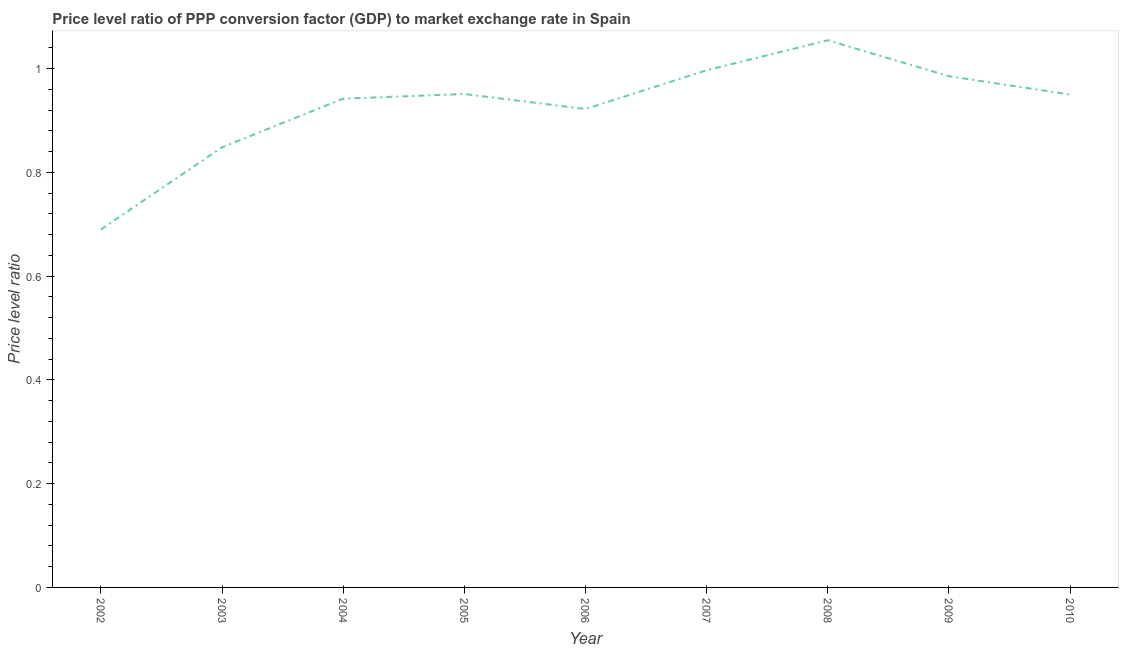What is the price level ratio in 2002?
Provide a succinct answer. 0.69. Across all years, what is the maximum price level ratio?
Your response must be concise. 1.05. Across all years, what is the minimum price level ratio?
Offer a terse response. 0.69. What is the sum of the price level ratio?
Give a very brief answer. 8.34. What is the difference between the price level ratio in 2004 and 2005?
Keep it short and to the point. -0.01. What is the average price level ratio per year?
Provide a short and direct response. 0.93. What is the median price level ratio?
Give a very brief answer. 0.95. Do a majority of the years between 2003 and 2008 (inclusive) have price level ratio greater than 0.56 ?
Your response must be concise. Yes. What is the ratio of the price level ratio in 2007 to that in 2010?
Provide a succinct answer. 1.05. Is the price level ratio in 2002 less than that in 2007?
Keep it short and to the point. Yes. Is the difference between the price level ratio in 2004 and 2008 greater than the difference between any two years?
Offer a terse response. No. What is the difference between the highest and the second highest price level ratio?
Provide a short and direct response. 0.06. Is the sum of the price level ratio in 2002 and 2010 greater than the maximum price level ratio across all years?
Provide a succinct answer. Yes. What is the difference between the highest and the lowest price level ratio?
Offer a terse response. 0.36. In how many years, is the price level ratio greater than the average price level ratio taken over all years?
Keep it short and to the point. 6. How many lines are there?
Your answer should be compact. 1. Does the graph contain any zero values?
Make the answer very short. No. Does the graph contain grids?
Ensure brevity in your answer.  No. What is the title of the graph?
Ensure brevity in your answer.  Price level ratio of PPP conversion factor (GDP) to market exchange rate in Spain. What is the label or title of the Y-axis?
Make the answer very short. Price level ratio. What is the Price level ratio in 2002?
Your answer should be compact. 0.69. What is the Price level ratio of 2003?
Your answer should be very brief. 0.85. What is the Price level ratio of 2004?
Provide a short and direct response. 0.94. What is the Price level ratio in 2005?
Your answer should be very brief. 0.95. What is the Price level ratio in 2006?
Offer a terse response. 0.92. What is the Price level ratio in 2007?
Offer a terse response. 1. What is the Price level ratio in 2008?
Make the answer very short. 1.05. What is the Price level ratio in 2009?
Your answer should be compact. 0.99. What is the Price level ratio of 2010?
Offer a very short reply. 0.95. What is the difference between the Price level ratio in 2002 and 2003?
Your response must be concise. -0.16. What is the difference between the Price level ratio in 2002 and 2004?
Ensure brevity in your answer.  -0.25. What is the difference between the Price level ratio in 2002 and 2005?
Make the answer very short. -0.26. What is the difference between the Price level ratio in 2002 and 2006?
Your answer should be very brief. -0.23. What is the difference between the Price level ratio in 2002 and 2007?
Provide a succinct answer. -0.31. What is the difference between the Price level ratio in 2002 and 2008?
Make the answer very short. -0.36. What is the difference between the Price level ratio in 2002 and 2009?
Give a very brief answer. -0.3. What is the difference between the Price level ratio in 2002 and 2010?
Provide a succinct answer. -0.26. What is the difference between the Price level ratio in 2003 and 2004?
Keep it short and to the point. -0.09. What is the difference between the Price level ratio in 2003 and 2005?
Offer a terse response. -0.1. What is the difference between the Price level ratio in 2003 and 2006?
Provide a succinct answer. -0.07. What is the difference between the Price level ratio in 2003 and 2007?
Provide a succinct answer. -0.15. What is the difference between the Price level ratio in 2003 and 2008?
Your response must be concise. -0.21. What is the difference between the Price level ratio in 2003 and 2009?
Offer a terse response. -0.14. What is the difference between the Price level ratio in 2003 and 2010?
Offer a very short reply. -0.1. What is the difference between the Price level ratio in 2004 and 2005?
Offer a terse response. -0.01. What is the difference between the Price level ratio in 2004 and 2006?
Make the answer very short. 0.02. What is the difference between the Price level ratio in 2004 and 2007?
Give a very brief answer. -0.05. What is the difference between the Price level ratio in 2004 and 2008?
Your response must be concise. -0.11. What is the difference between the Price level ratio in 2004 and 2009?
Your answer should be compact. -0.04. What is the difference between the Price level ratio in 2004 and 2010?
Provide a succinct answer. -0.01. What is the difference between the Price level ratio in 2005 and 2006?
Keep it short and to the point. 0.03. What is the difference between the Price level ratio in 2005 and 2007?
Make the answer very short. -0.05. What is the difference between the Price level ratio in 2005 and 2008?
Ensure brevity in your answer.  -0.1. What is the difference between the Price level ratio in 2005 and 2009?
Offer a terse response. -0.03. What is the difference between the Price level ratio in 2005 and 2010?
Your response must be concise. 0. What is the difference between the Price level ratio in 2006 and 2007?
Your answer should be very brief. -0.07. What is the difference between the Price level ratio in 2006 and 2008?
Provide a short and direct response. -0.13. What is the difference between the Price level ratio in 2006 and 2009?
Your response must be concise. -0.06. What is the difference between the Price level ratio in 2006 and 2010?
Offer a terse response. -0.03. What is the difference between the Price level ratio in 2007 and 2008?
Offer a terse response. -0.06. What is the difference between the Price level ratio in 2007 and 2009?
Provide a succinct answer. 0.01. What is the difference between the Price level ratio in 2007 and 2010?
Provide a succinct answer. 0.05. What is the difference between the Price level ratio in 2008 and 2009?
Your response must be concise. 0.07. What is the difference between the Price level ratio in 2008 and 2010?
Ensure brevity in your answer.  0.1. What is the difference between the Price level ratio in 2009 and 2010?
Provide a succinct answer. 0.04. What is the ratio of the Price level ratio in 2002 to that in 2003?
Your answer should be very brief. 0.81. What is the ratio of the Price level ratio in 2002 to that in 2004?
Ensure brevity in your answer.  0.73. What is the ratio of the Price level ratio in 2002 to that in 2005?
Your answer should be very brief. 0.73. What is the ratio of the Price level ratio in 2002 to that in 2006?
Keep it short and to the point. 0.75. What is the ratio of the Price level ratio in 2002 to that in 2007?
Your response must be concise. 0.69. What is the ratio of the Price level ratio in 2002 to that in 2008?
Make the answer very short. 0.65. What is the ratio of the Price level ratio in 2002 to that in 2009?
Keep it short and to the point. 0.7. What is the ratio of the Price level ratio in 2002 to that in 2010?
Your answer should be very brief. 0.73. What is the ratio of the Price level ratio in 2003 to that in 2004?
Your answer should be very brief. 0.9. What is the ratio of the Price level ratio in 2003 to that in 2005?
Provide a short and direct response. 0.89. What is the ratio of the Price level ratio in 2003 to that in 2006?
Your answer should be very brief. 0.92. What is the ratio of the Price level ratio in 2003 to that in 2007?
Provide a short and direct response. 0.85. What is the ratio of the Price level ratio in 2003 to that in 2008?
Your answer should be compact. 0.8. What is the ratio of the Price level ratio in 2003 to that in 2009?
Your response must be concise. 0.86. What is the ratio of the Price level ratio in 2003 to that in 2010?
Your response must be concise. 0.89. What is the ratio of the Price level ratio in 2004 to that in 2006?
Ensure brevity in your answer.  1.02. What is the ratio of the Price level ratio in 2004 to that in 2007?
Offer a very short reply. 0.94. What is the ratio of the Price level ratio in 2004 to that in 2008?
Give a very brief answer. 0.89. What is the ratio of the Price level ratio in 2004 to that in 2009?
Provide a succinct answer. 0.96. What is the ratio of the Price level ratio in 2004 to that in 2010?
Your answer should be very brief. 0.99. What is the ratio of the Price level ratio in 2005 to that in 2006?
Provide a succinct answer. 1.03. What is the ratio of the Price level ratio in 2005 to that in 2007?
Offer a terse response. 0.95. What is the ratio of the Price level ratio in 2005 to that in 2008?
Your answer should be very brief. 0.9. What is the ratio of the Price level ratio in 2005 to that in 2010?
Your answer should be very brief. 1. What is the ratio of the Price level ratio in 2006 to that in 2007?
Your answer should be very brief. 0.93. What is the ratio of the Price level ratio in 2006 to that in 2008?
Give a very brief answer. 0.87. What is the ratio of the Price level ratio in 2006 to that in 2009?
Your answer should be compact. 0.94. What is the ratio of the Price level ratio in 2006 to that in 2010?
Ensure brevity in your answer.  0.97. What is the ratio of the Price level ratio in 2007 to that in 2008?
Offer a very short reply. 0.94. What is the ratio of the Price level ratio in 2007 to that in 2010?
Your answer should be very brief. 1.05. What is the ratio of the Price level ratio in 2008 to that in 2009?
Keep it short and to the point. 1.07. What is the ratio of the Price level ratio in 2008 to that in 2010?
Make the answer very short. 1.11. What is the ratio of the Price level ratio in 2009 to that in 2010?
Your answer should be compact. 1.04. 